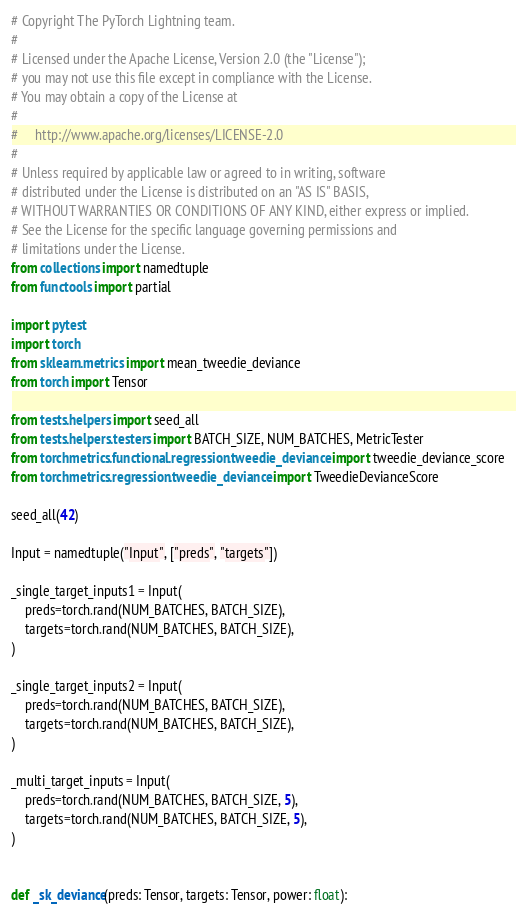Convert code to text. <code><loc_0><loc_0><loc_500><loc_500><_Python_># Copyright The PyTorch Lightning team.
#
# Licensed under the Apache License, Version 2.0 (the "License");
# you may not use this file except in compliance with the License.
# You may obtain a copy of the License at
#
#     http://www.apache.org/licenses/LICENSE-2.0
#
# Unless required by applicable law or agreed to in writing, software
# distributed under the License is distributed on an "AS IS" BASIS,
# WITHOUT WARRANTIES OR CONDITIONS OF ANY KIND, either express or implied.
# See the License for the specific language governing permissions and
# limitations under the License.
from collections import namedtuple
from functools import partial

import pytest
import torch
from sklearn.metrics import mean_tweedie_deviance
from torch import Tensor

from tests.helpers import seed_all
from tests.helpers.testers import BATCH_SIZE, NUM_BATCHES, MetricTester
from torchmetrics.functional.regression.tweedie_deviance import tweedie_deviance_score
from torchmetrics.regression.tweedie_deviance import TweedieDevianceScore

seed_all(42)

Input = namedtuple("Input", ["preds", "targets"])

_single_target_inputs1 = Input(
    preds=torch.rand(NUM_BATCHES, BATCH_SIZE),
    targets=torch.rand(NUM_BATCHES, BATCH_SIZE),
)

_single_target_inputs2 = Input(
    preds=torch.rand(NUM_BATCHES, BATCH_SIZE),
    targets=torch.rand(NUM_BATCHES, BATCH_SIZE),
)

_multi_target_inputs = Input(
    preds=torch.rand(NUM_BATCHES, BATCH_SIZE, 5),
    targets=torch.rand(NUM_BATCHES, BATCH_SIZE, 5),
)


def _sk_deviance(preds: Tensor, targets: Tensor, power: float):</code> 